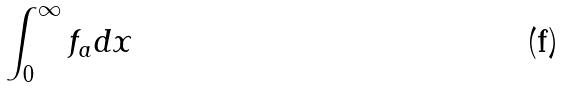<formula> <loc_0><loc_0><loc_500><loc_500>\int _ { 0 } ^ { \infty } f _ { a } d x</formula> 